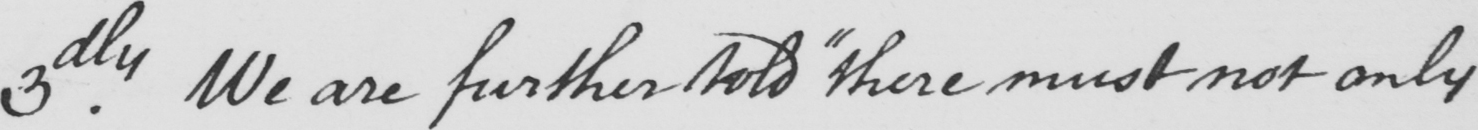What is written in this line of handwriting? 3.dly We are further told  " there must not only 